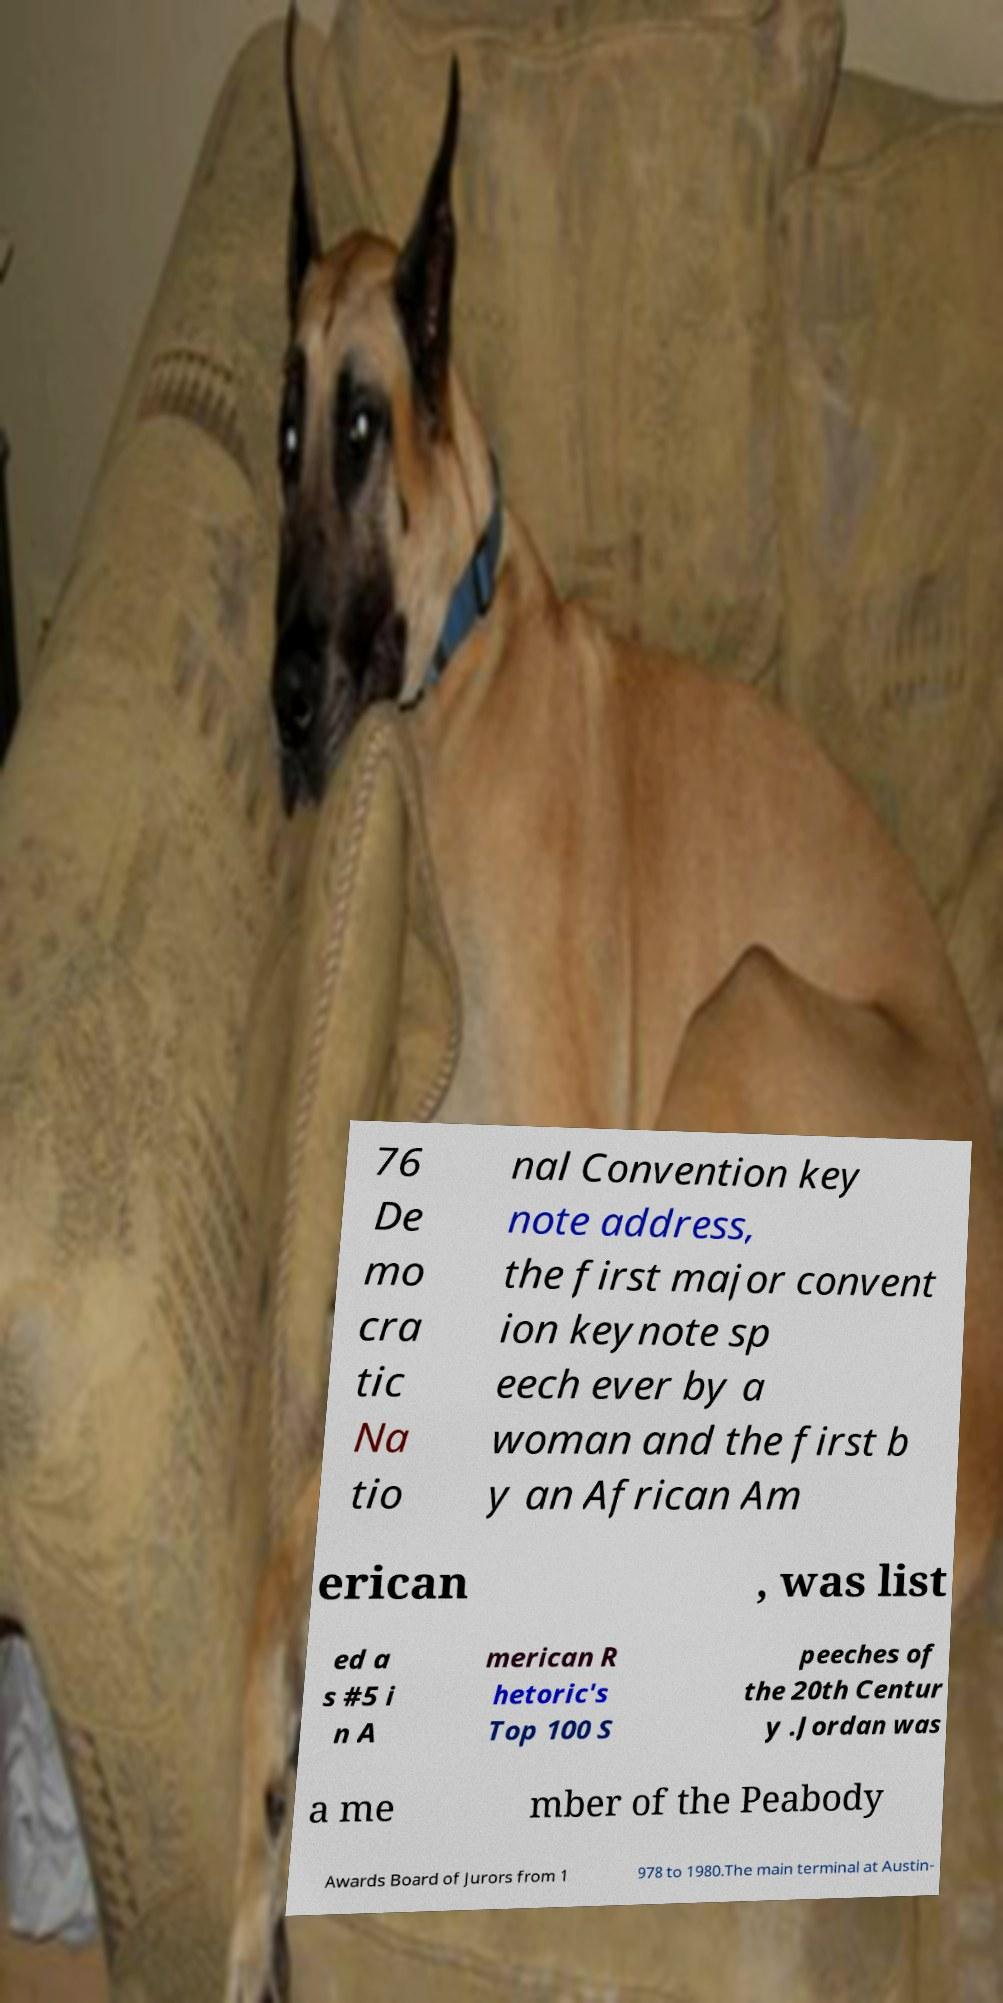For documentation purposes, I need the text within this image transcribed. Could you provide that? 76 De mo cra tic Na tio nal Convention key note address, the first major convent ion keynote sp eech ever by a woman and the first b y an African Am erican , was list ed a s #5 i n A merican R hetoric's Top 100 S peeches of the 20th Centur y .Jordan was a me mber of the Peabody Awards Board of Jurors from 1 978 to 1980.The main terminal at Austin- 